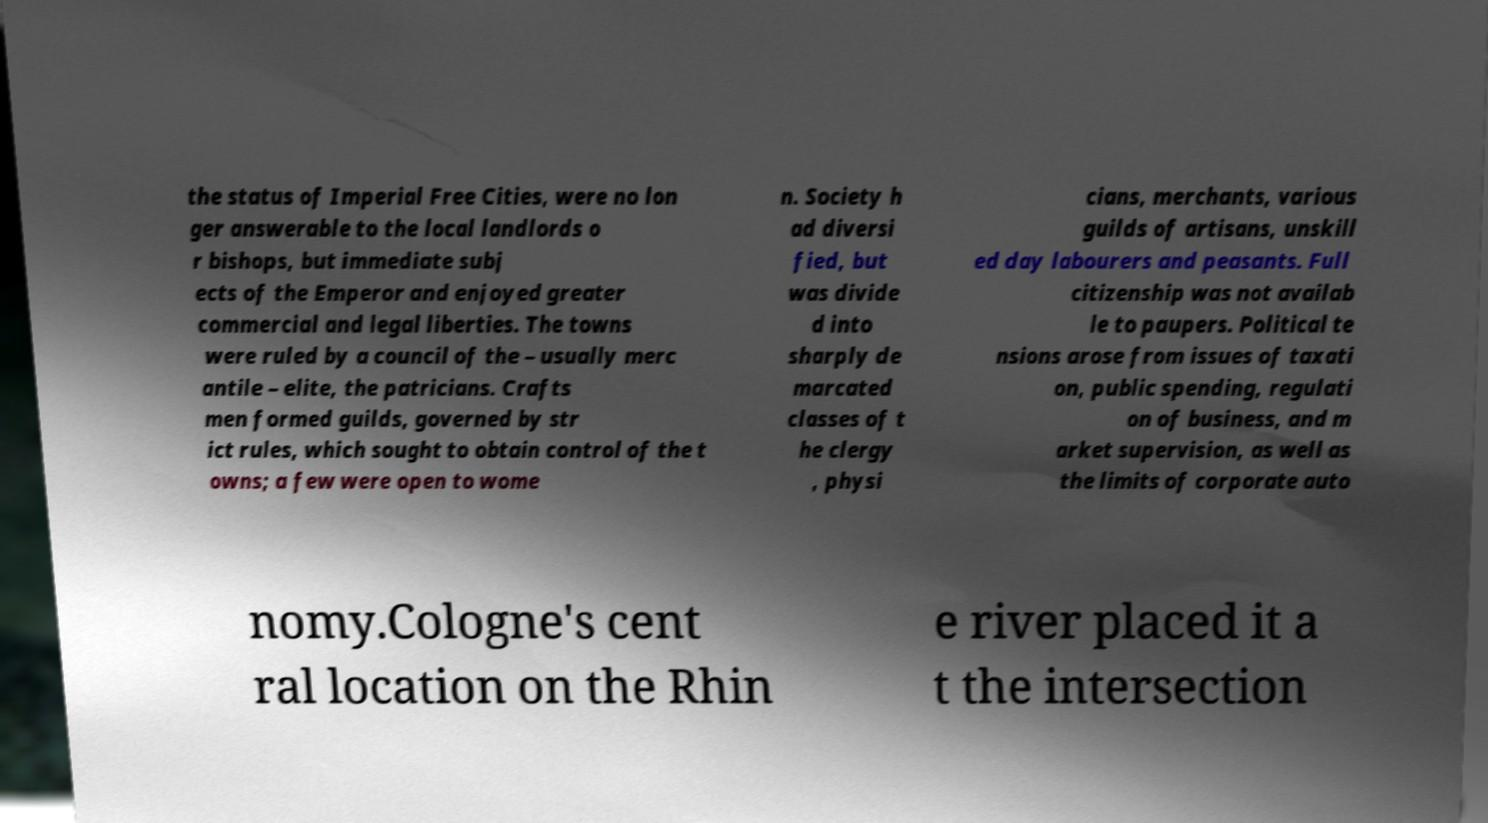Please read and relay the text visible in this image. What does it say? the status of Imperial Free Cities, were no lon ger answerable to the local landlords o r bishops, but immediate subj ects of the Emperor and enjoyed greater commercial and legal liberties. The towns were ruled by a council of the – usually merc antile – elite, the patricians. Crafts men formed guilds, governed by str ict rules, which sought to obtain control of the t owns; a few were open to wome n. Society h ad diversi fied, but was divide d into sharply de marcated classes of t he clergy , physi cians, merchants, various guilds of artisans, unskill ed day labourers and peasants. Full citizenship was not availab le to paupers. Political te nsions arose from issues of taxati on, public spending, regulati on of business, and m arket supervision, as well as the limits of corporate auto nomy.Cologne's cent ral location on the Rhin e river placed it a t the intersection 